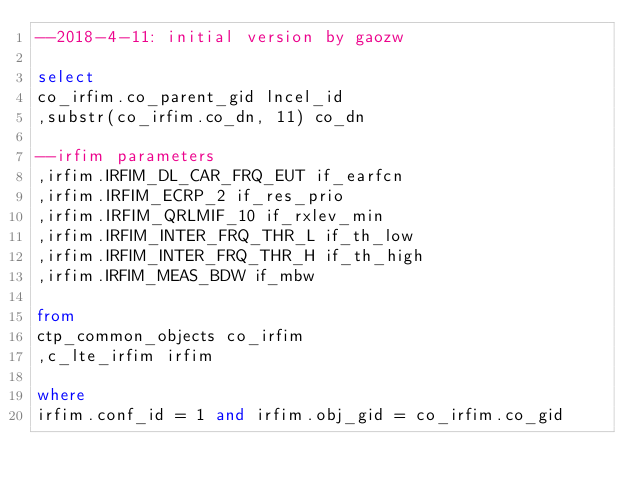<code> <loc_0><loc_0><loc_500><loc_500><_SQL_>--2018-4-11: initial version by gaozw

select
co_irfim.co_parent_gid lncel_id
,substr(co_irfim.co_dn, 11) co_dn

--irfim parameters
,irfim.IRFIM_DL_CAR_FRQ_EUT if_earfcn
,irfim.IRFIM_ECRP_2 if_res_prio
,irfim.IRFIM_QRLMIF_10 if_rxlev_min
,irfim.IRFIM_INTER_FRQ_THR_L if_th_low
,irfim.IRFIM_INTER_FRQ_THR_H if_th_high 
,irfim.IRFIM_MEAS_BDW if_mbw

from
ctp_common_objects co_irfim
,c_lte_irfim irfim

where
irfim.conf_id = 1 and irfim.obj_gid = co_irfim.co_gid
</code> 